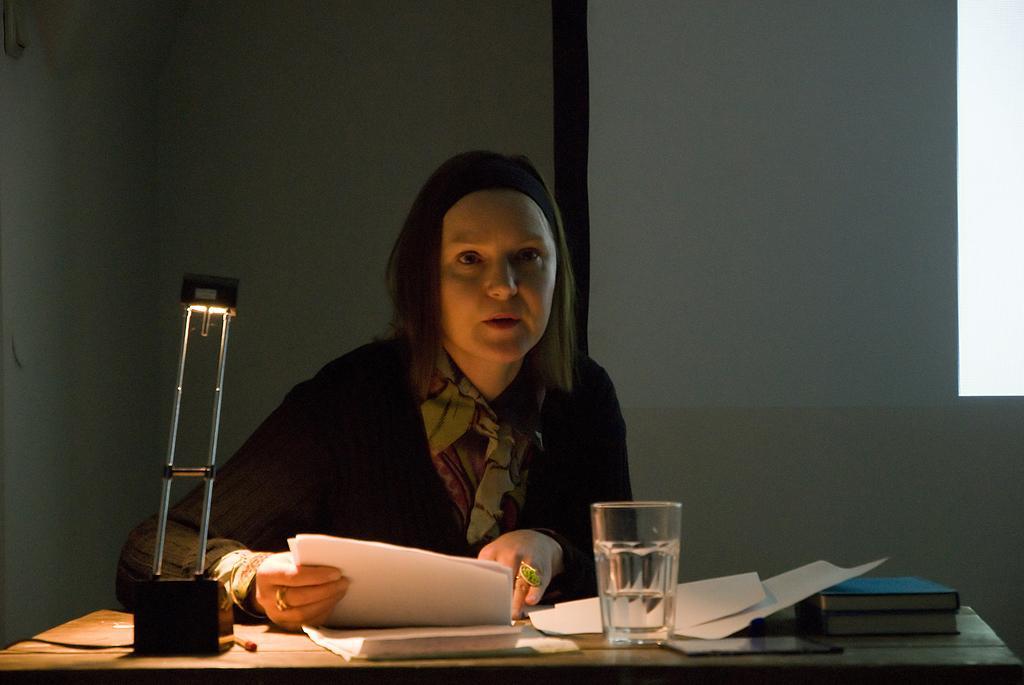How would you summarize this image in a sentence or two? She is sitting on a chair. She is holding a paper. There is a table. There is a glass,paper,books and mobile phone on a table. 